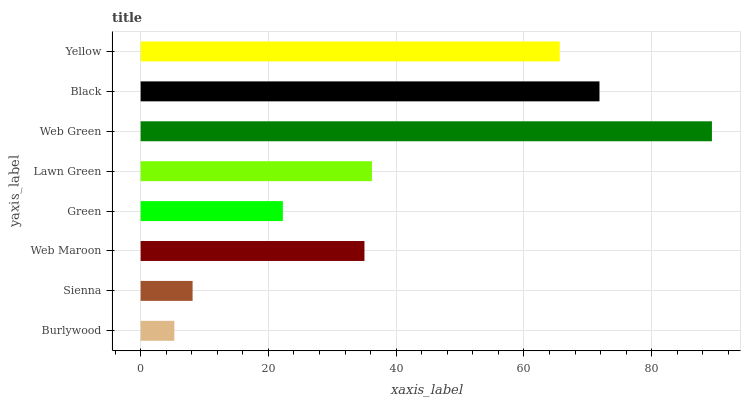Is Burlywood the minimum?
Answer yes or no. Yes. Is Web Green the maximum?
Answer yes or no. Yes. Is Sienna the minimum?
Answer yes or no. No. Is Sienna the maximum?
Answer yes or no. No. Is Sienna greater than Burlywood?
Answer yes or no. Yes. Is Burlywood less than Sienna?
Answer yes or no. Yes. Is Burlywood greater than Sienna?
Answer yes or no. No. Is Sienna less than Burlywood?
Answer yes or no. No. Is Lawn Green the high median?
Answer yes or no. Yes. Is Web Maroon the low median?
Answer yes or no. Yes. Is Web Green the high median?
Answer yes or no. No. Is Burlywood the low median?
Answer yes or no. No. 